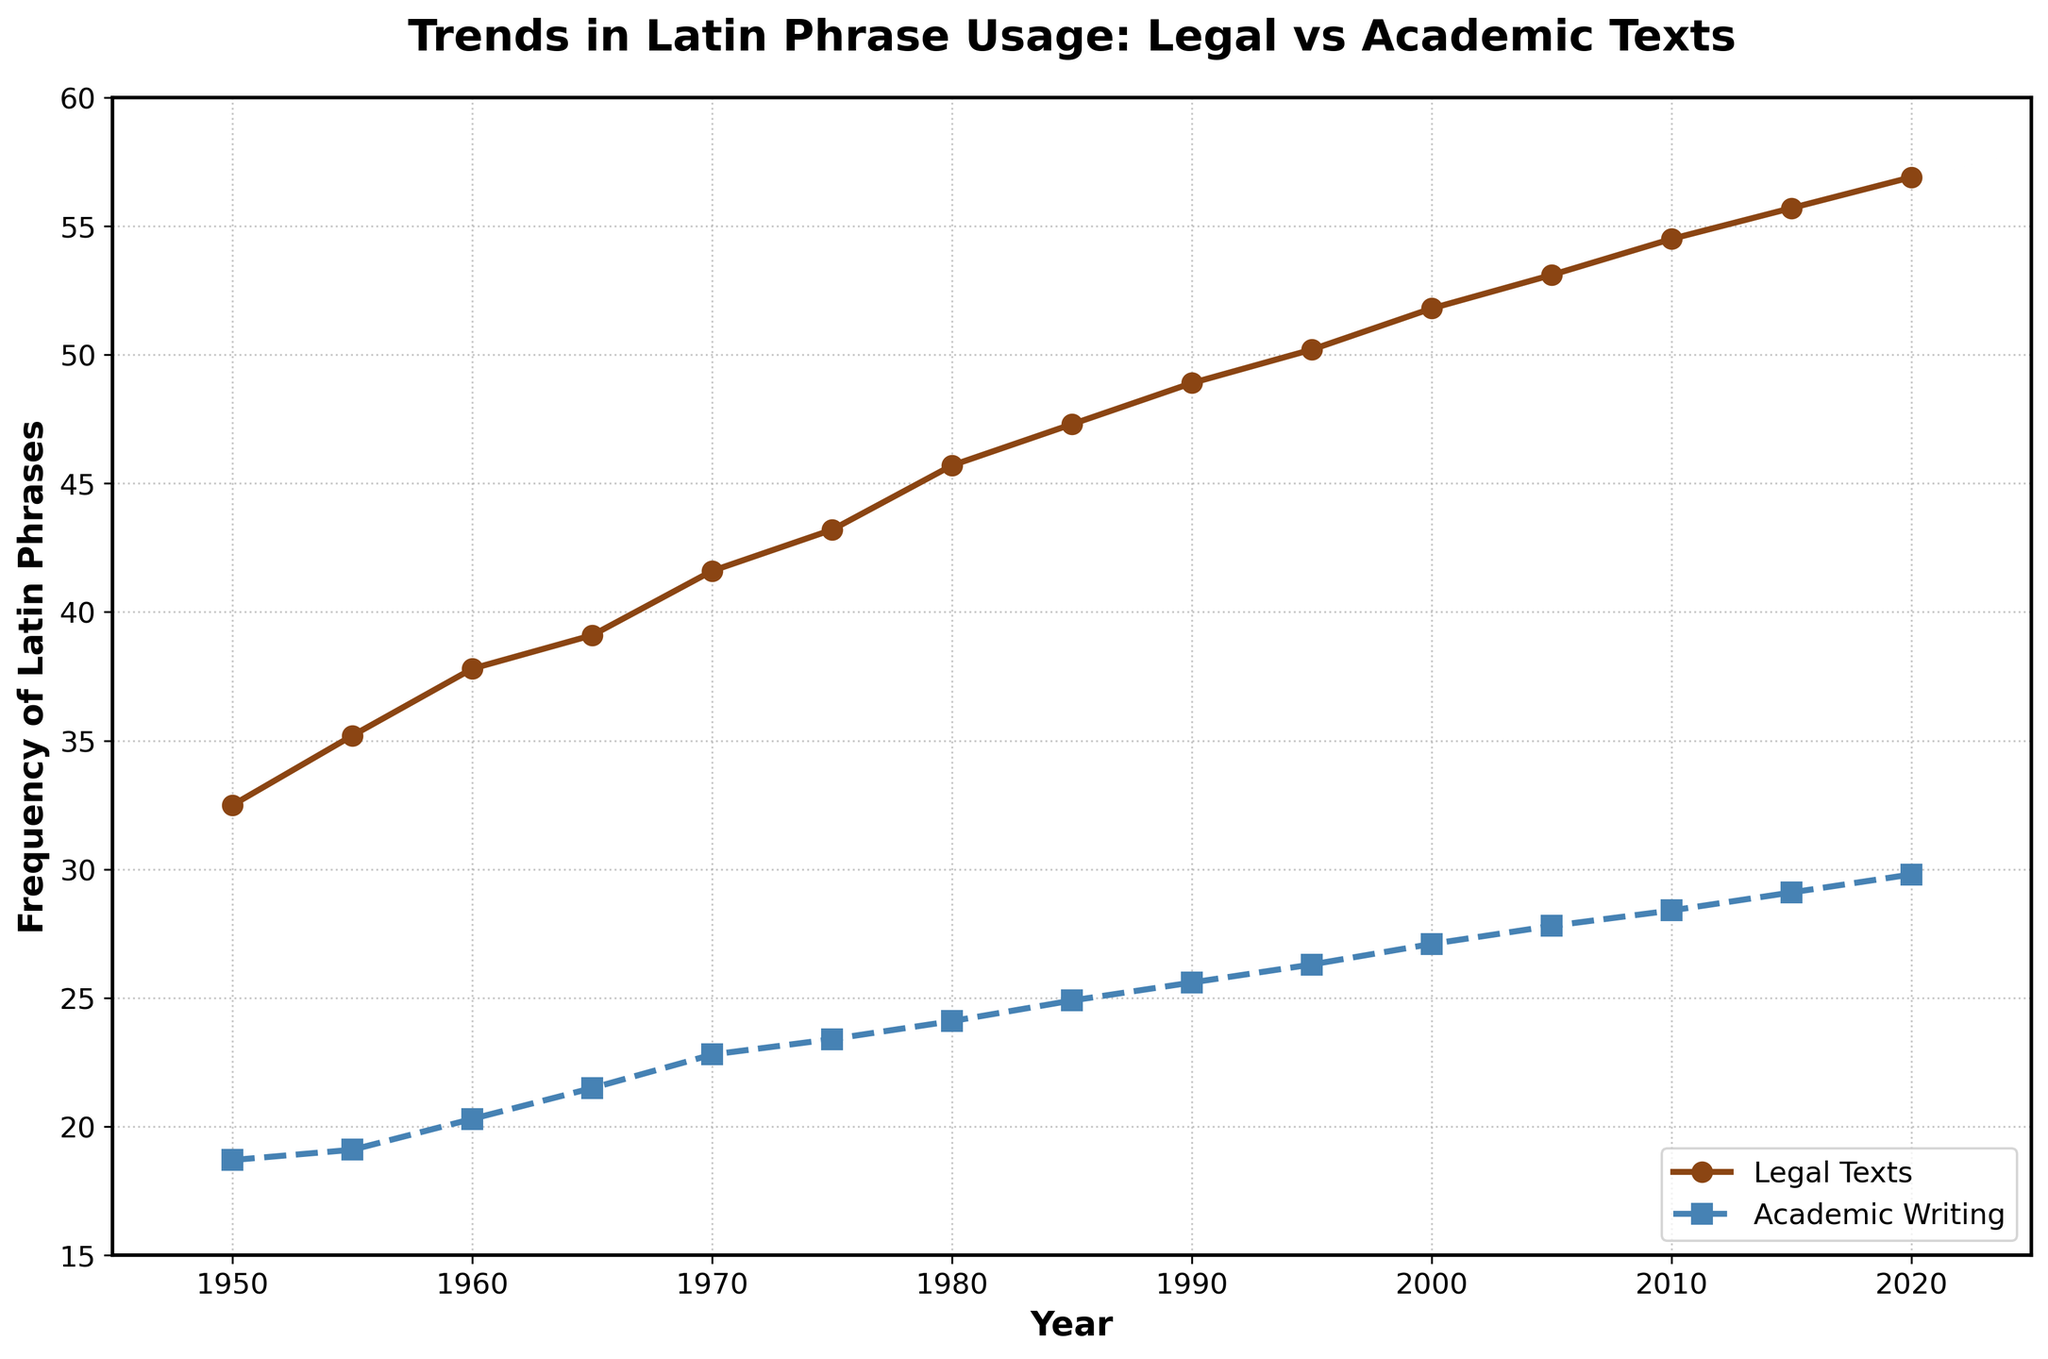What year does the frequency of Latin phrases in legal texts first surpass 40? Locate the line representing legal texts, and find the year where its frequency first exceeds 40.
Answer: 1970 What is the increase in the frequency of Latin phrases in academic writing from 1950 to 2020? Subtract the frequency in 1950 from the frequency in 2020 for academic writing (i.e., 29.8 - 18.7).
Answer: 11.1 During which decade did the frequency of Latin phrases in legal texts show the greatest increase? Identify the decade by looking at the sharpest rise in the line representing legal texts. The largest increase from one decade to the next can be found by comparing the start and end points of each decade segment.
Answer: 1950 to 1960 By how much did the use of Latin phrases in academic writing increase between 2000 and 2020? Compare the values of academic writing in 2000 and 2020 (i.e., 29.8 - 27.1).
Answer: 2.7 Which text type had a higher frequency of Latin phrases in 1980? Observe the frequency values for both legal texts and academic writing in 1980.
Answer: Legal Texts In 2010, by how much did the frequency of Latin phrases in legal texts exceed that in academic writing? Calculate the difference between the 2010 values for legal texts and academic writing (i.e., 54.5 - 28.4).
Answer: 26.1 What is the average frequency of Latin phrases in academic writing over the 70-year period? Calculate the average by summing all the frequencies for academic writing from 1950 to 2020, then dividing by the number of years considered (15 values in total).
Values: 18.7, 19.1, 20.3, 21.5, 22.8, 23.4, 24.1, 24.9, 25.6, 26.3, 27.1, 27.8, 28.4, 29.1, 29.8
Sum: 368.9, Average: 368.9/15 = 24.59 (rounded to two decimal places)
Answer: 24.59 By how much did the frequency of Latin phrases in legal texts increase from 1950 to 2000? Compare the values of legal texts in 1950 and 2000 (i.e., 51.8 - 32.5).
Answer: 19.3 